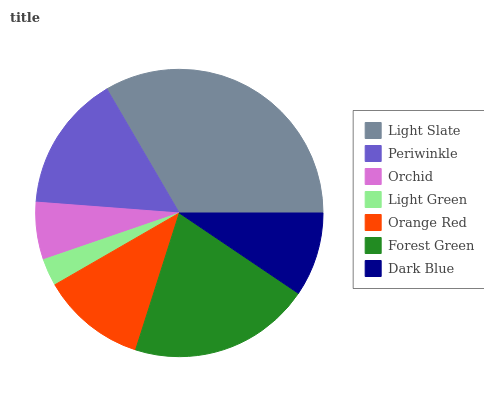Is Light Green the minimum?
Answer yes or no. Yes. Is Light Slate the maximum?
Answer yes or no. Yes. Is Periwinkle the minimum?
Answer yes or no. No. Is Periwinkle the maximum?
Answer yes or no. No. Is Light Slate greater than Periwinkle?
Answer yes or no. Yes. Is Periwinkle less than Light Slate?
Answer yes or no. Yes. Is Periwinkle greater than Light Slate?
Answer yes or no. No. Is Light Slate less than Periwinkle?
Answer yes or no. No. Is Orange Red the high median?
Answer yes or no. Yes. Is Orange Red the low median?
Answer yes or no. Yes. Is Dark Blue the high median?
Answer yes or no. No. Is Periwinkle the low median?
Answer yes or no. No. 